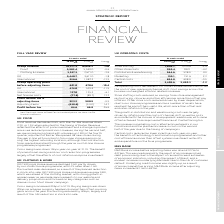From Marks And Spencer Group Plc's financial document, What is the operating costs of store staffing in 2019 and 2018 respectively? The document shows two values: 1,044.7 and 1,070.6 (in millions). From the document: "Store staffing 1,044.7 1,070.6 -2.4 Store staffing 1,044.7 1,070.6 -2.4..." Also, What is the operating costs of Other store costs in 2019 and 2018 respectively? The document shows two values: 950.4 and 992.1 (in millions). From the document: "Other store costs 950.4 992.1 -4.2 Other store costs 950.4 992.1 -4.2..." Also, What is the operating costs of Distribution & warehousing in 2019 and 2018 respectively? The document shows two values: 564.6 and 538.0 (in millions). From the document: "Distribution & warehousing 564.6 538.0 4.9 Distribution & warehousing 564.6 538.0 4.9..." Additionally, Which year had a higher operating costs of store staffing? Based on the financial document, the answer is 2018. Also, can you calculate: What is the change in Marketing costs between 2018 and 2019? Based on the calculation: 155.1-151.6, the result is 3.5 (in millions). This is based on the information: "Marketing 155.1 151.6 2.3 Marketing 155.1 151.6 2.3..." The key data points involved are: 151.6, 155.1. Also, can you calculate: What is the average marketing costs for 2018 and 2019? To answer this question, I need to perform calculations using the financial data. The calculation is: (155.1+ 151.6)/2, which equals 153.35 (in millions). This is based on the information: "Marketing 155.1 151.6 2.3 Marketing 155.1 151.6 2.3..." The key data points involved are: 151.6, 155.1. 